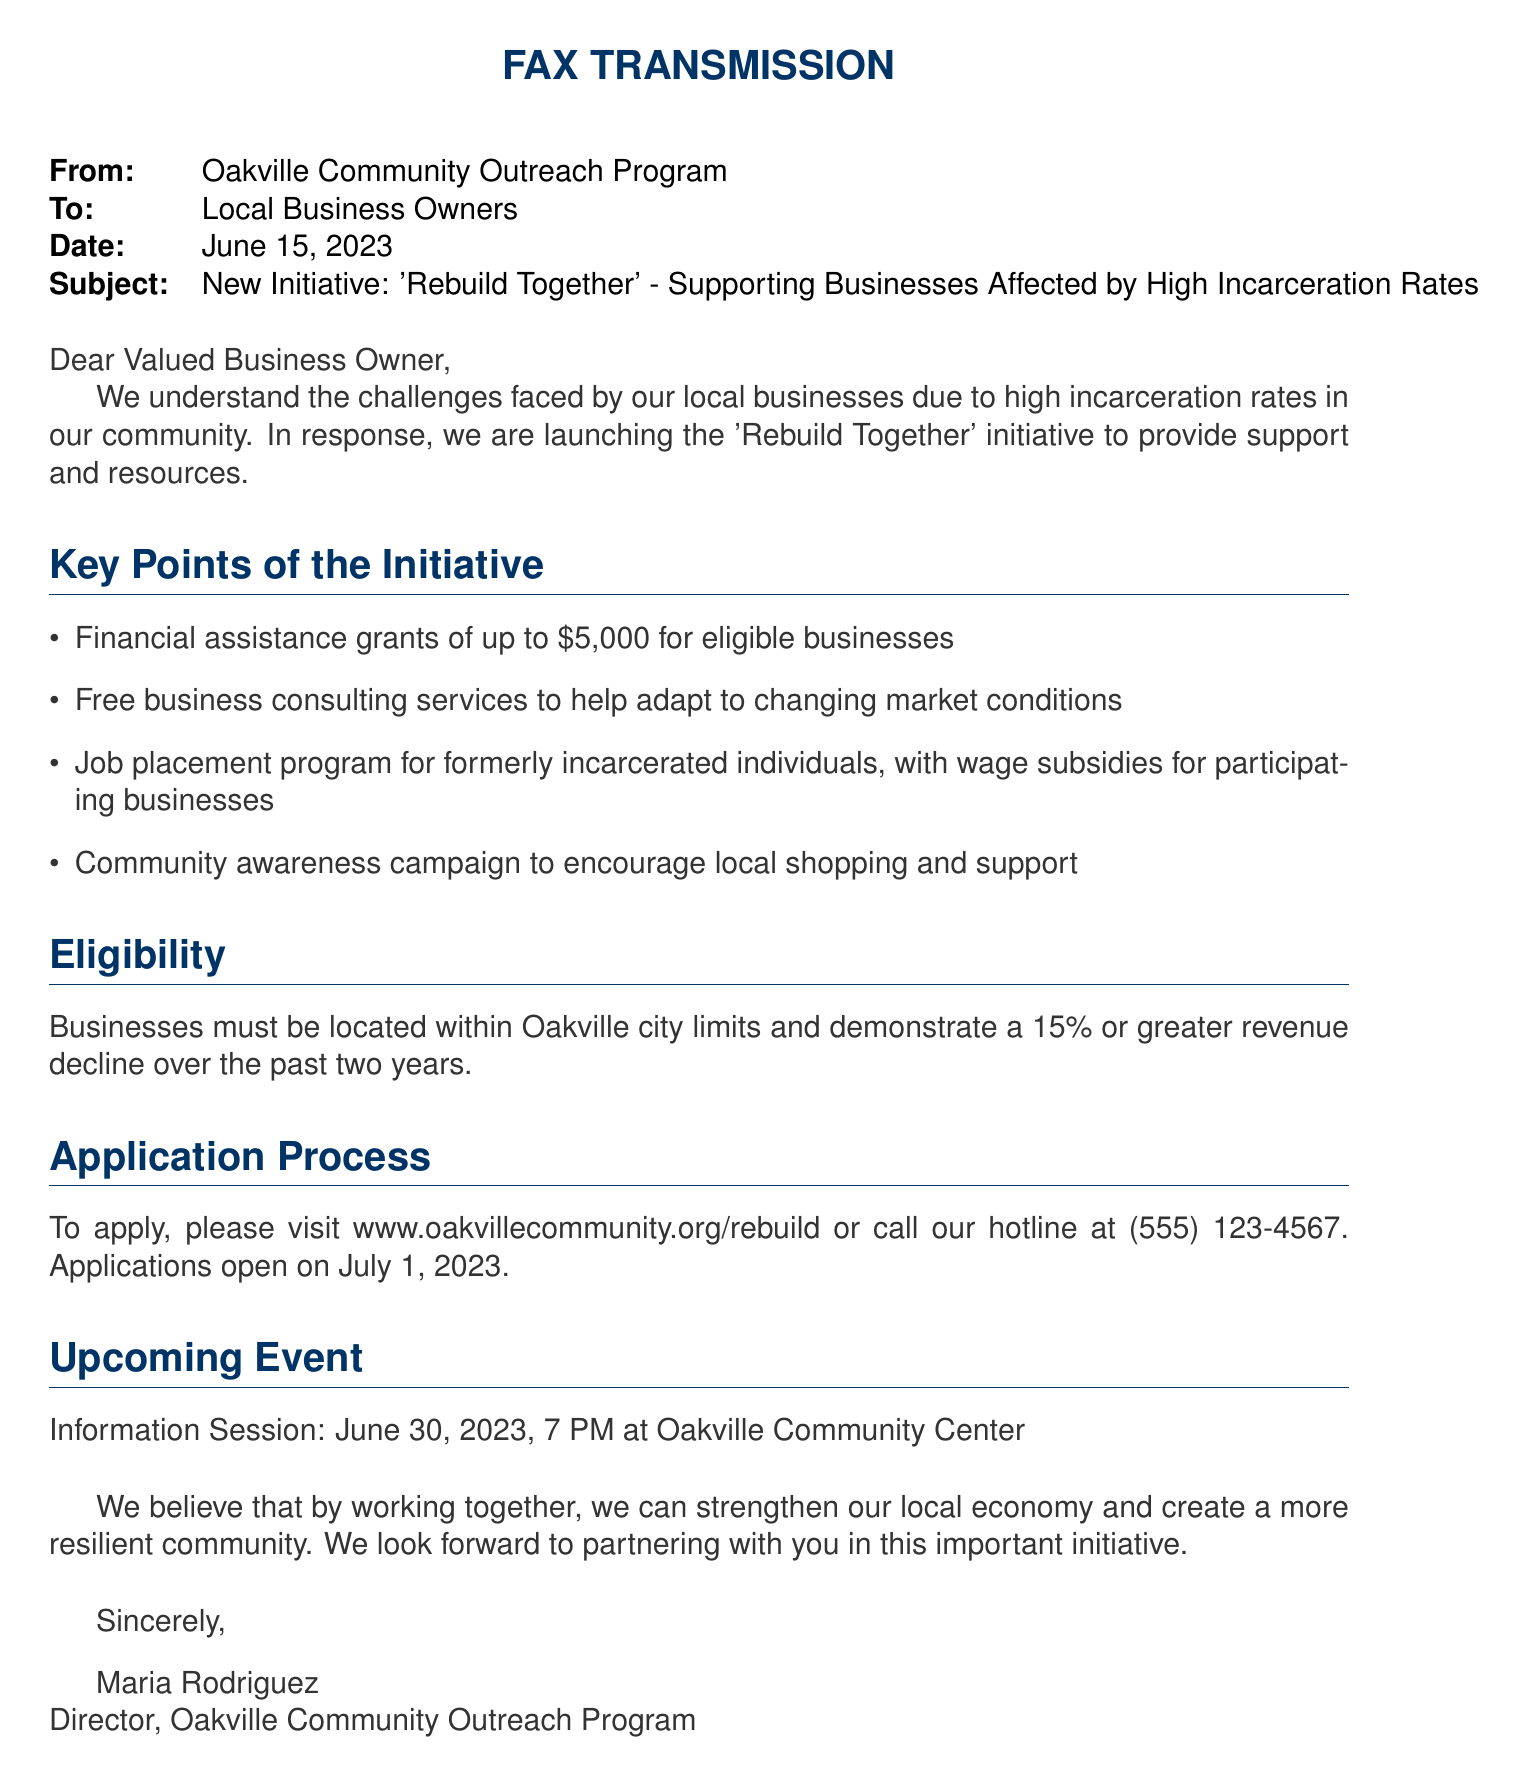What is the name of the initiative? The name of the initiative is 'Rebuild Together'.
Answer: 'Rebuild Together' What is the maximum financial assistance amount? The document states that financial assistance grants of up to $5,000 are available.
Answer: $5,000 When do applications open? The document mentions that applications will open on July 1, 2023.
Answer: July 1, 2023 What percentage decline in revenue must businesses demonstrate? Businesses must demonstrate a 15% or greater revenue decline.
Answer: 15% Where is the information session taking place? The information session is taking place at Oakville Community Center.
Answer: Oakville Community Center Who is the director of the Oakville Community Outreach Program? The director's name is Maria Rodriguez.
Answer: Maria Rodriguez What type of services are being offered to businesses? Free business consulting services are being offered.
Answer: Free business consulting services What is the date of the information session? The information session is scheduled for June 30, 2023.
Answer: June 30, 2023 What type of program is included to assist formerly incarcerated individuals? The document mentions a job placement program.
Answer: Job placement program 